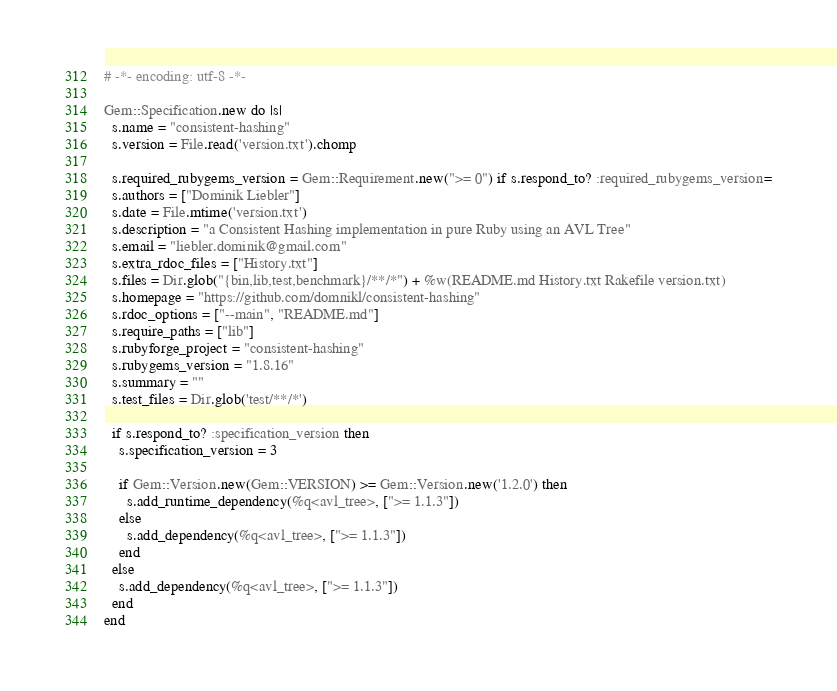<code> <loc_0><loc_0><loc_500><loc_500><_Ruby_># -*- encoding: utf-8 -*-

Gem::Specification.new do |s|
  s.name = "consistent-hashing"
  s.version = File.read('version.txt').chomp

  s.required_rubygems_version = Gem::Requirement.new(">= 0") if s.respond_to? :required_rubygems_version=
  s.authors = ["Dominik Liebler"]
  s.date = File.mtime('version.txt')
  s.description = "a Consistent Hashing implementation in pure Ruby using an AVL Tree"
  s.email = "liebler.dominik@gmail.com"
  s.extra_rdoc_files = ["History.txt"]
  s.files = Dir.glob("{bin,lib,test,benchmark}/**/*") + %w(README.md History.txt Rakefile version.txt)
  s.homepage = "https://github.com/domnikl/consistent-hashing"
  s.rdoc_options = ["--main", "README.md"]
  s.require_paths = ["lib"]
  s.rubyforge_project = "consistent-hashing"
  s.rubygems_version = "1.8.16"
  s.summary = ""
  s.test_files = Dir.glob('test/**/*')

  if s.respond_to? :specification_version then
    s.specification_version = 3

    if Gem::Version.new(Gem::VERSION) >= Gem::Version.new('1.2.0') then
      s.add_runtime_dependency(%q<avl_tree>, [">= 1.1.3"])
    else
      s.add_dependency(%q<avl_tree>, [">= 1.1.3"])
    end
  else
    s.add_dependency(%q<avl_tree>, [">= 1.1.3"])
  end
end
</code> 